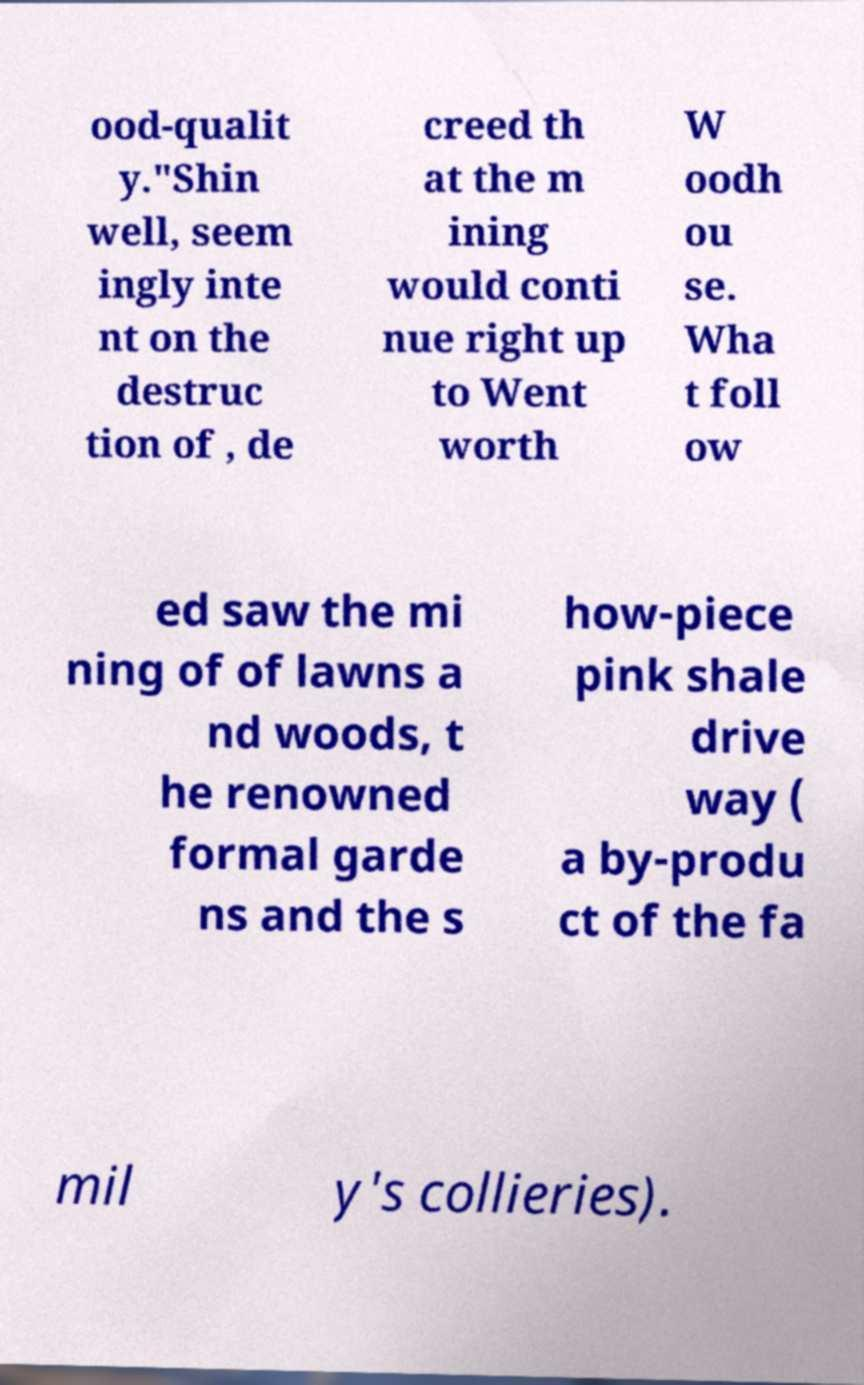Can you accurately transcribe the text from the provided image for me? ood-qualit y."Shin well, seem ingly inte nt on the destruc tion of , de creed th at the m ining would conti nue right up to Went worth W oodh ou se. Wha t foll ow ed saw the mi ning of of lawns a nd woods, t he renowned formal garde ns and the s how-piece pink shale drive way ( a by-produ ct of the fa mil y's collieries). 